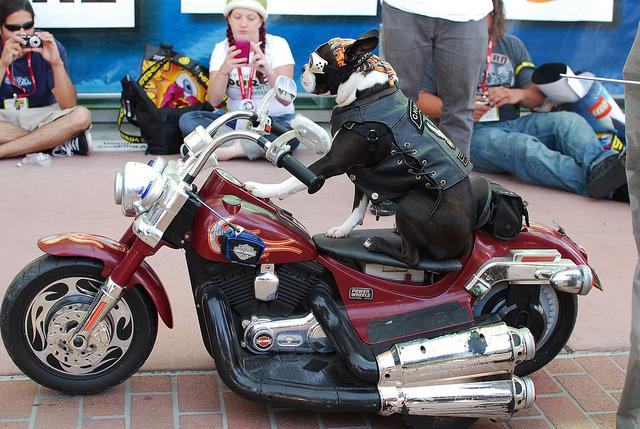Is the dog enjoying the ride?
Quick response, please. Yes. What is the dog sitting on?
Quick response, please. Motorcycle. What is on the scooter?
Be succinct. Dog. What is the dog looking at?
Be succinct. People. What is the dog on the right looking at?
Write a very short answer. People. What is the purpose of the blue facilities in the background?
Be succinct. Wall. What is the man sitting on?
Answer briefly. Ground. How many wheels does this thing have?
Keep it brief. 2. What color sign is on the back of the motorcycle?
Give a very brief answer. Black. Is everyone wearing pants?
Short answer required. No. Is the motorcycle white and black?
Keep it brief. No. What animals are sitting on the bike?
Concise answer only. Dog. What are the women taking a picture of?
Write a very short answer. Dog on motorcycle. What color lanyard is the woman in the top left wearing?
Concise answer only. Red. Is he a professional?
Write a very short answer. No. Is the dog driving?
Be succinct. No. Where are they parked?
Concise answer only. Sidewalk. What is the dog wearing?
Quick response, please. Jacket. What does the dog have on his neck?
Short answer required. Collar. How fast can the green scooter go?
Be succinct. No green scooter. How many people are in the picture?
Give a very brief answer. 4. How many bikes are visible?
Keep it brief. 1. What color is the gas tank?
Give a very brief answer. Red. Is this a real motorcycle?
Give a very brief answer. No. What is the couple doing?
Short answer required. Sitting. Is this indoors our outside?
Quick response, please. Outside. What is on the man's head?
Be succinct. Hat. What is the number on the engine?
Answer briefly. 0. 